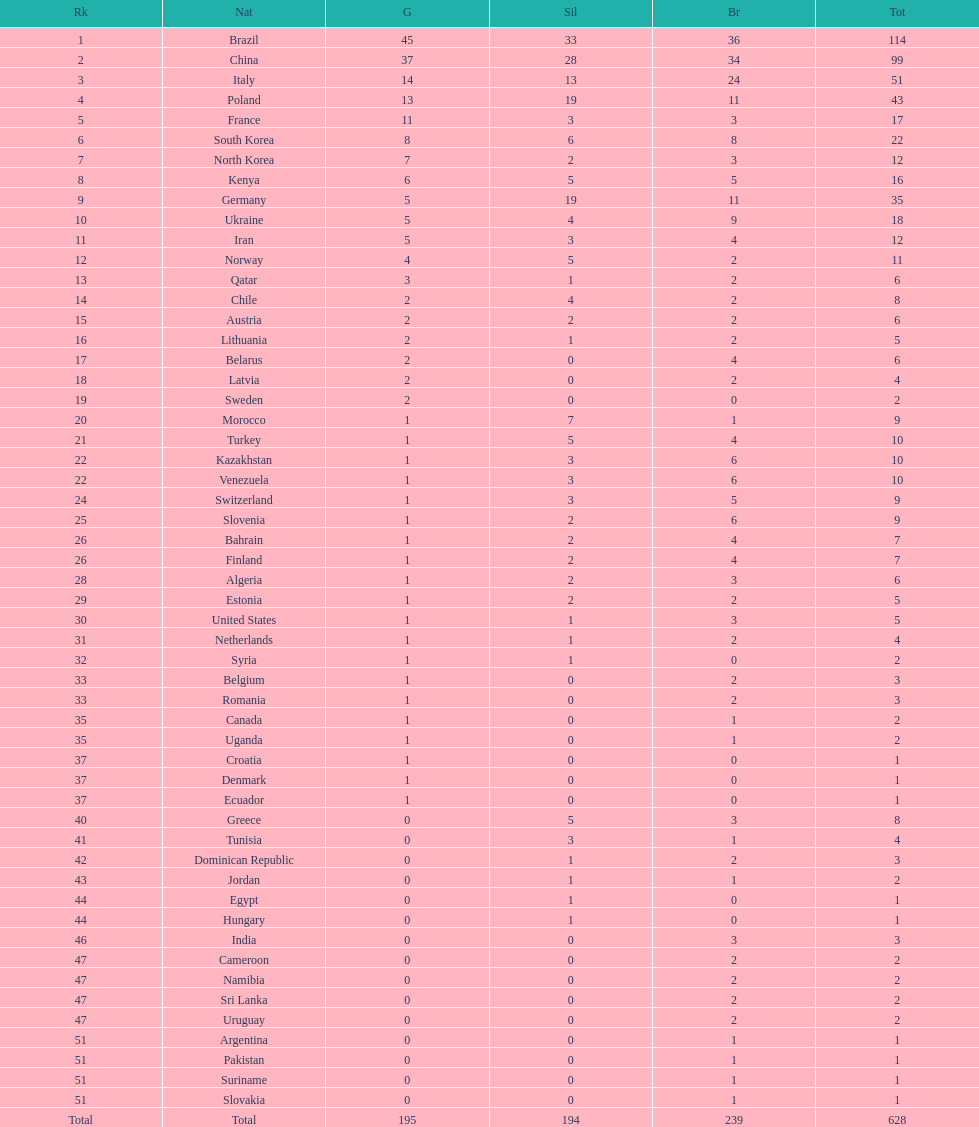What is the total number of medals between south korea, north korea, sweden, and brazil? 150. 